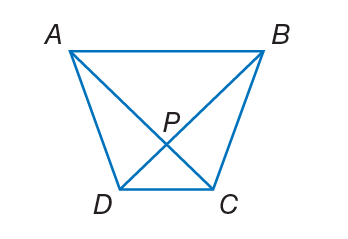Answer the mathemtical geometry problem and directly provide the correct option letter.
Question: A B C D is a trapezoid. If A C = 3 x - 7 and B D = 2 x + 8, find the value of x so that A B C D is isosceles.
Choices: A: 15 B: 20 C: 28 D: 38 A 